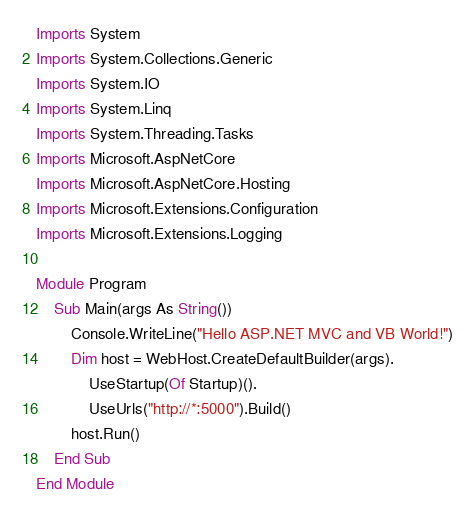Convert code to text. <code><loc_0><loc_0><loc_500><loc_500><_VisualBasic_>Imports System
Imports System.Collections.Generic
Imports System.IO
Imports System.Linq
Imports System.Threading.Tasks
Imports Microsoft.AspNetCore
Imports Microsoft.AspNetCore.Hosting
Imports Microsoft.Extensions.Configuration
Imports Microsoft.Extensions.Logging

Module Program
    Sub Main(args As String())
        Console.WriteLine("Hello ASP.NET MVC and VB World!")
        Dim host = WebHost.CreateDefaultBuilder(args).
            UseStartup(Of Startup)().
            UseUrls("http://*:5000").Build()
        host.Run()
    End Sub
End Module
</code> 